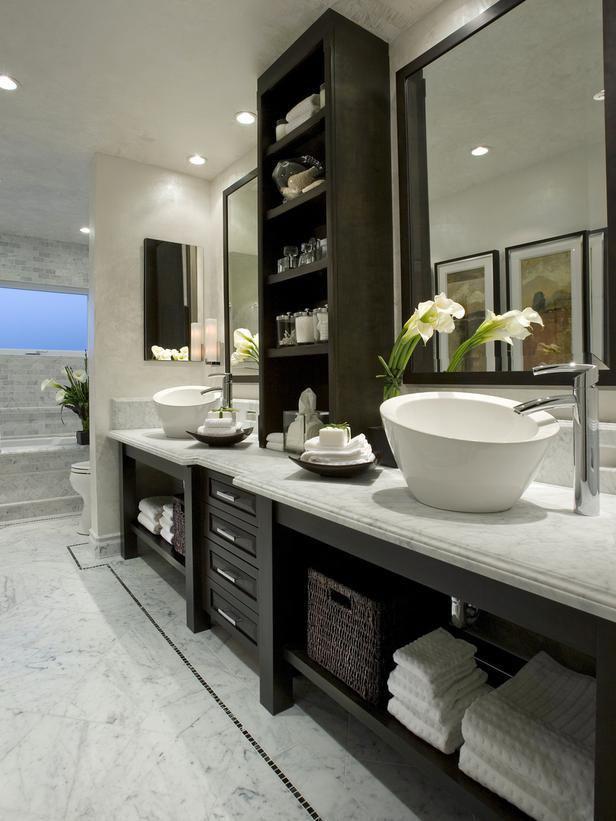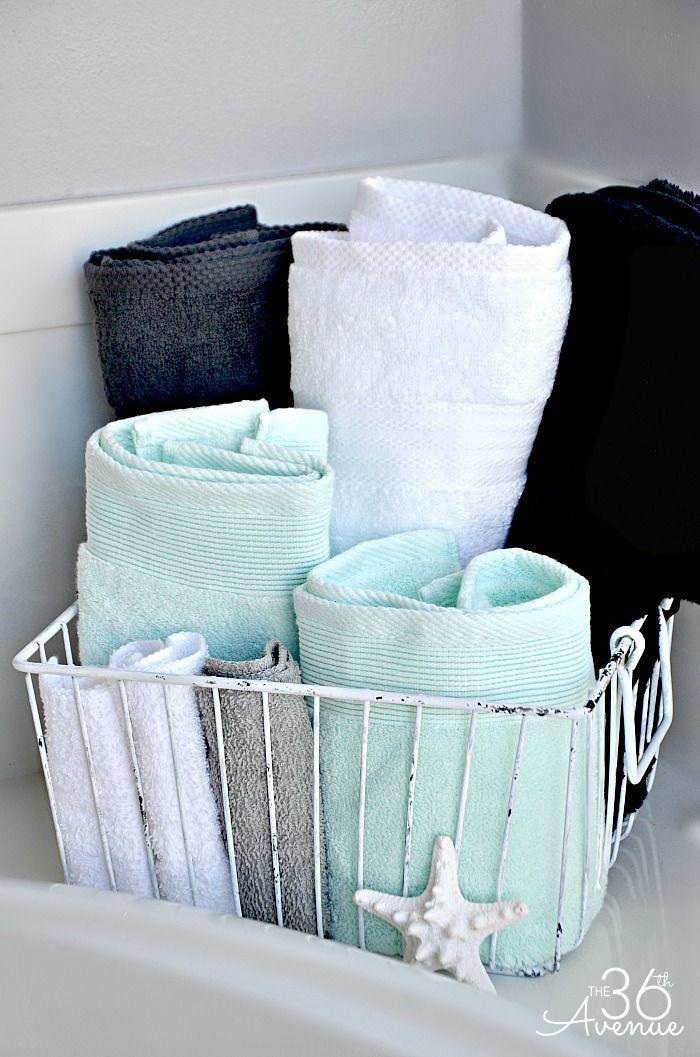The first image is the image on the left, the second image is the image on the right. For the images displayed, is the sentence "In one image, two towels hang side by side on one bar." factually correct? Answer yes or no. No. The first image is the image on the left, the second image is the image on the right. Given the left and right images, does the statement "A wall mounted bathroom sink is in one image." hold true? Answer yes or no. No. 